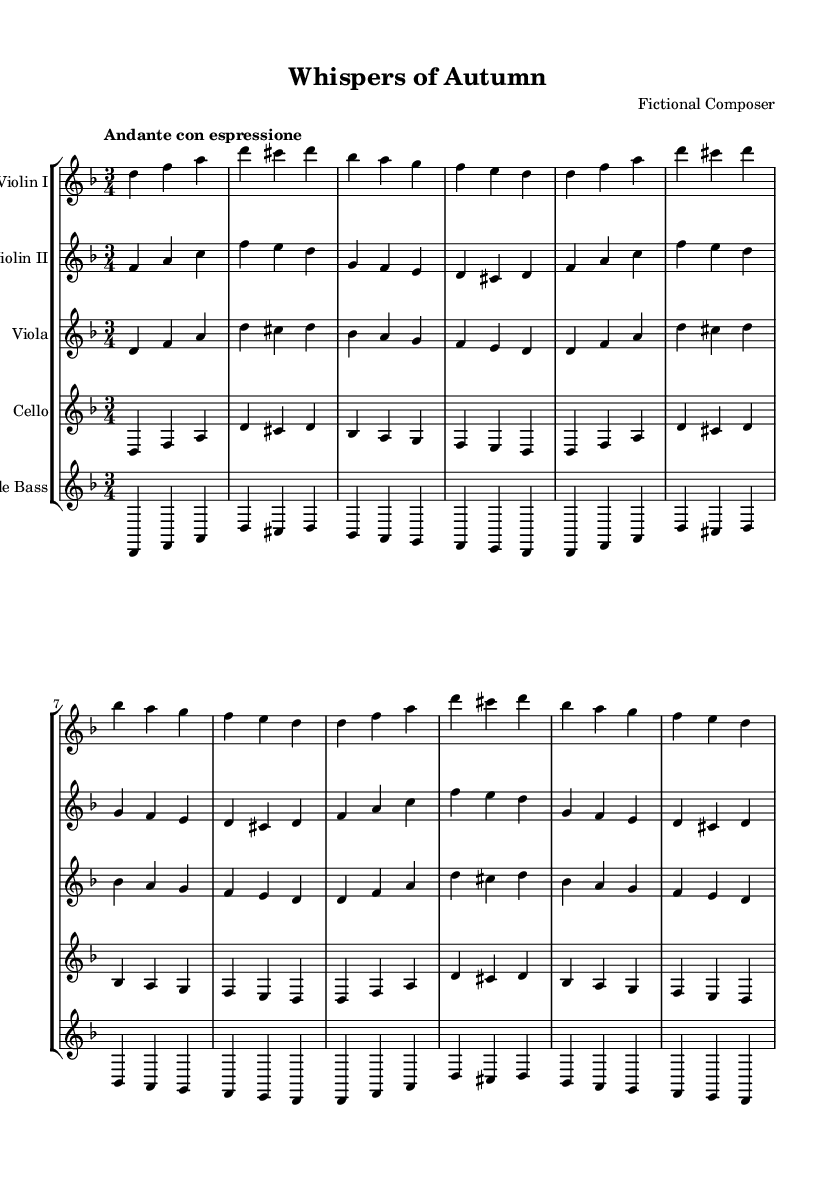What is the key signature of this music? The key signature is D minor, which includes one flat (B flat) indicating that B will be flattened throughout this piece.
Answer: D minor What is the time signature of this music? The time signature indicated at the beginning of the score is 3/4, which indicates three beats per measure with a quarter note receiving one beat.
Answer: 3/4 What is the indicated tempo for this piece? The tempo marking is "Andante con espressione," suggesting a moderate pace with expressiveness, typically slower than a walking pace.
Answer: Andante con espressione How many instruments are in this chamber music piece? The score shows five different staffs, indicating five instruments: two violins, a viola, a cello, and a double bass.
Answer: Five Which instrument plays the melody primarily in the first section? The first violin is typically the primary carrier of the melody, as it often has the highest pitch and typically plays the most prominent lines.
Answer: Violin I What is the repeated musical figure in the strings? Each instrument showcases a repeated pattern that includes the notes D, F, and A in various arrangements. They repeat sections of their music, emphasizing the thematic material.
Answer: D, F, A What is the general character conveyed by the tempo and dynamics in this Romantic-era piece? The combination of "Andante con espressione" suggests a lyrical and expressive character typical of Romantic music, where emotional nuance is key.
Answer: Expressive 